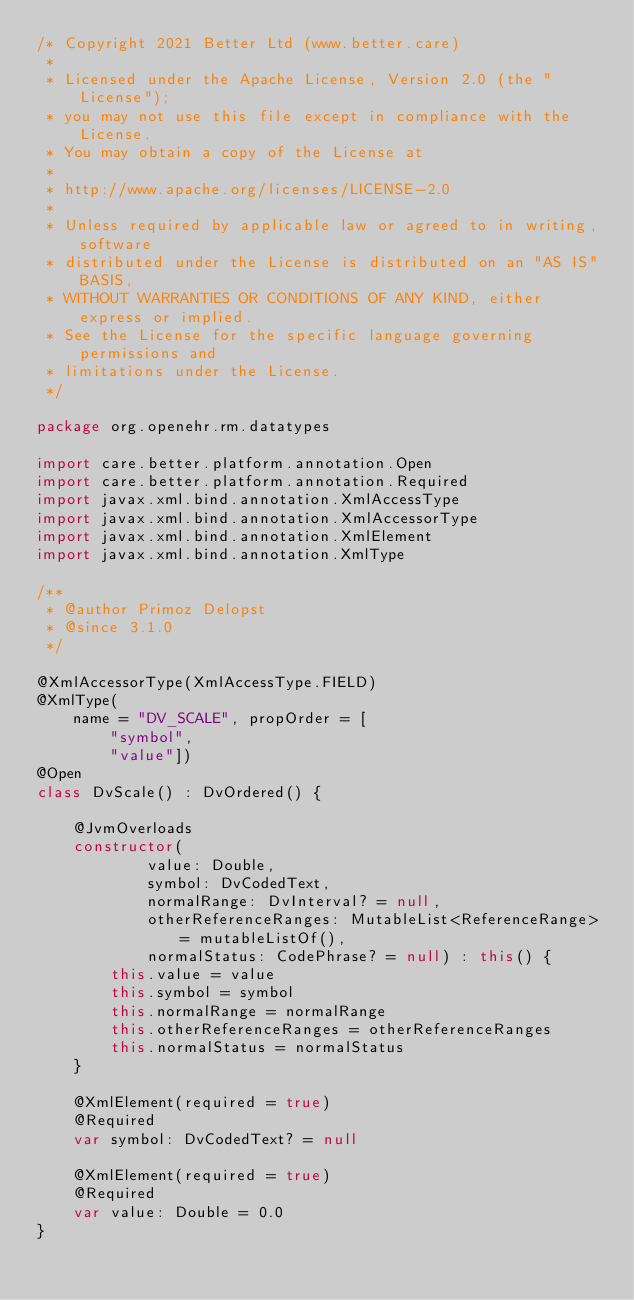Convert code to text. <code><loc_0><loc_0><loc_500><loc_500><_Kotlin_>/* Copyright 2021 Better Ltd (www.better.care)
 *
 * Licensed under the Apache License, Version 2.0 (the "License");
 * you may not use this file except in compliance with the License.
 * You may obtain a copy of the License at
 *
 * http://www.apache.org/licenses/LICENSE-2.0
 *
 * Unless required by applicable law or agreed to in writing, software
 * distributed under the License is distributed on an "AS IS" BASIS,
 * WITHOUT WARRANTIES OR CONDITIONS OF ANY KIND, either express or implied.
 * See the License for the specific language governing permissions and
 * limitations under the License.
 */

package org.openehr.rm.datatypes

import care.better.platform.annotation.Open
import care.better.platform.annotation.Required
import javax.xml.bind.annotation.XmlAccessType
import javax.xml.bind.annotation.XmlAccessorType
import javax.xml.bind.annotation.XmlElement
import javax.xml.bind.annotation.XmlType

/**
 * @author Primoz Delopst
 * @since 3.1.0
 */

@XmlAccessorType(XmlAccessType.FIELD)
@XmlType(
    name = "DV_SCALE", propOrder = [
        "symbol",
        "value"])
@Open
class DvScale() : DvOrdered() {

    @JvmOverloads
    constructor(
            value: Double,
            symbol: DvCodedText,
            normalRange: DvInterval? = null,
            otherReferenceRanges: MutableList<ReferenceRange> = mutableListOf(),
            normalStatus: CodePhrase? = null) : this() {
        this.value = value
        this.symbol = symbol
        this.normalRange = normalRange
        this.otherReferenceRanges = otherReferenceRanges
        this.normalStatus = normalStatus
    }

    @XmlElement(required = true)
    @Required
    var symbol: DvCodedText? = null

    @XmlElement(required = true)
    @Required
    var value: Double = 0.0
}
</code> 